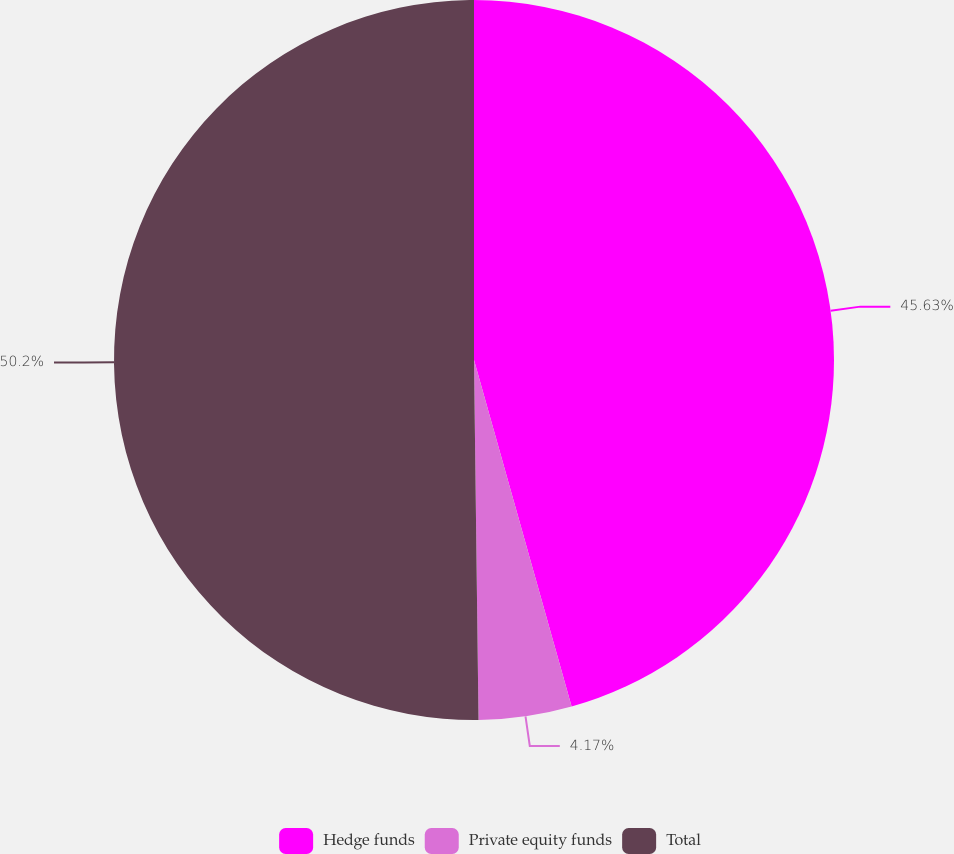Convert chart to OTSL. <chart><loc_0><loc_0><loc_500><loc_500><pie_chart><fcel>Hedge funds<fcel>Private equity funds<fcel>Total<nl><fcel>45.63%<fcel>4.17%<fcel>50.2%<nl></chart> 